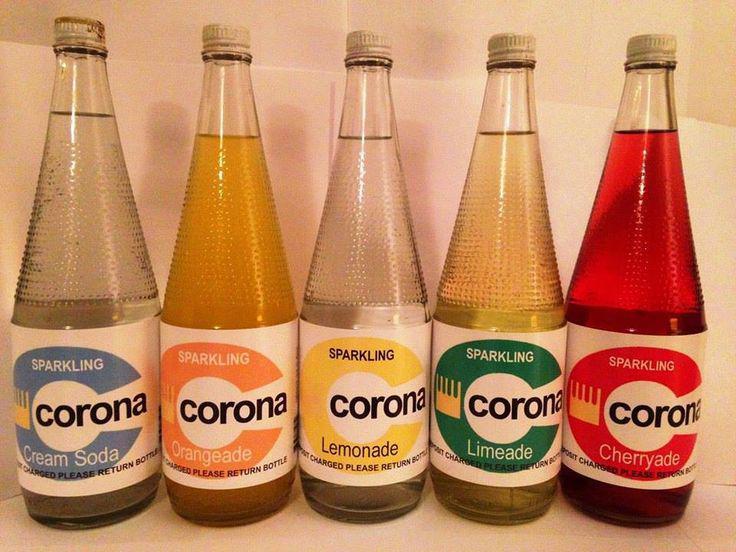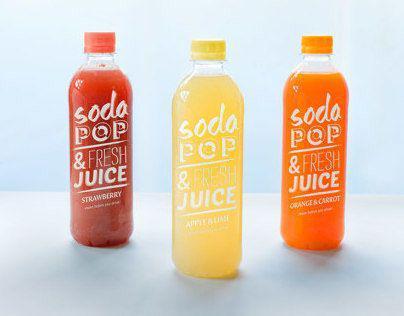The first image is the image on the left, the second image is the image on the right. Given the left and right images, does the statement "There are at least 3 green soda bottles within the rows of bottles." hold true? Answer yes or no. No. The first image is the image on the left, the second image is the image on the right. For the images displayed, is the sentence "All bottles have labels on them, and no bottles are in boxes." factually correct? Answer yes or no. Yes. 